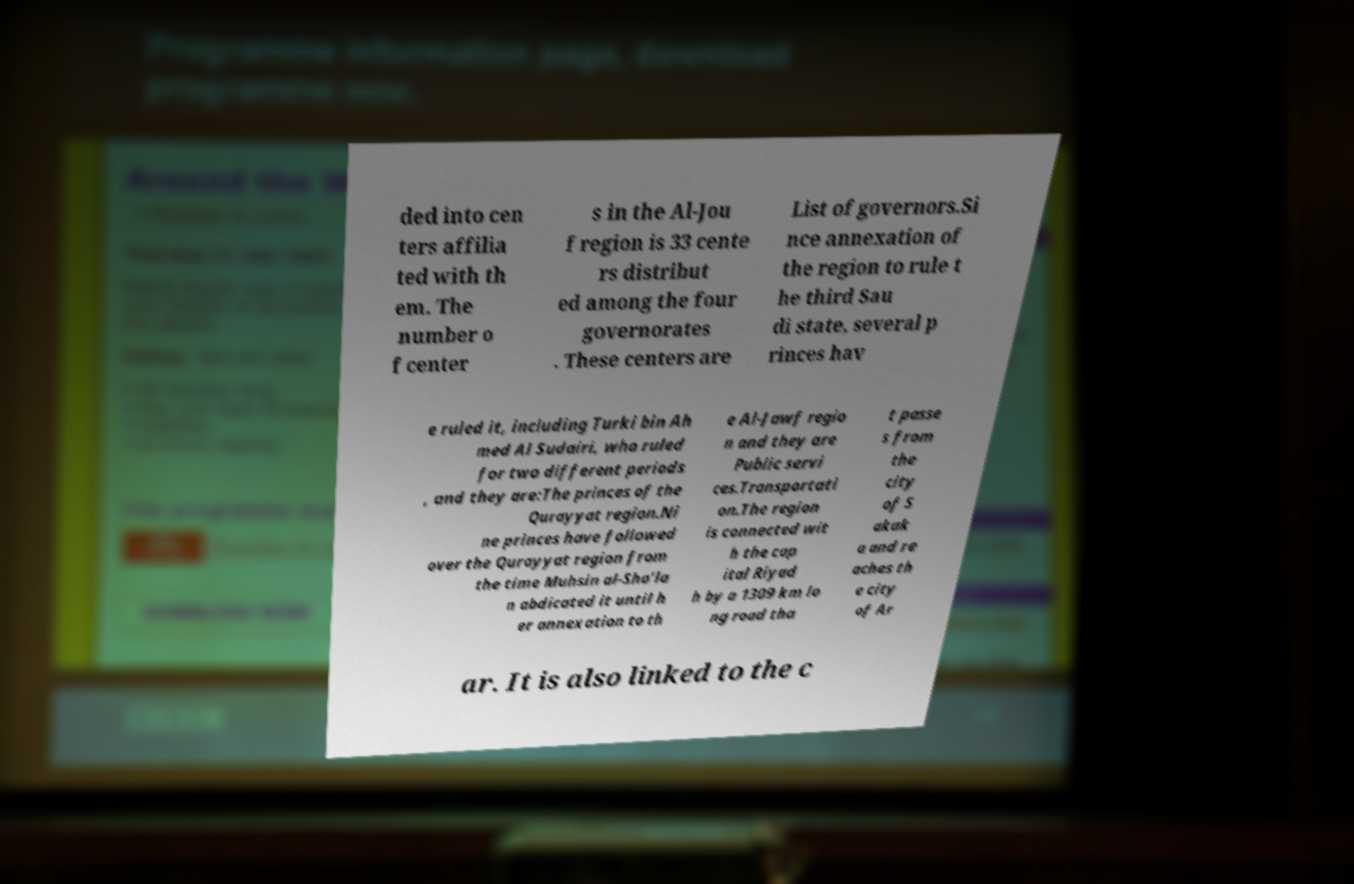For documentation purposes, I need the text within this image transcribed. Could you provide that? ded into cen ters affilia ted with th em. The number o f center s in the Al-Jou f region is 33 cente rs distribut ed among the four governorates . These centers are List of governors.Si nce annexation of the region to rule t he third Sau di state, several p rinces hav e ruled it, including Turki bin Ah med Al Sudairi, who ruled for two different periods , and they are:The princes of the Qurayyat region.Ni ne princes have followed over the Qurayyat region from the time Muhsin al-Sha’la n abdicated it until h er annexation to th e Al-Jawf regio n and they are Public servi ces.Transportati on.The region is connected wit h the cap ital Riyad h by a 1309 km lo ng road tha t passe s from the city of S akak a and re aches th e city of Ar ar. It is also linked to the c 